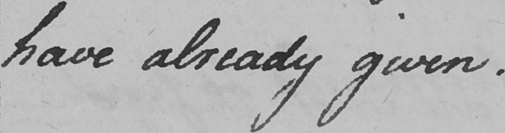Please transcribe the handwritten text in this image. have already given . 